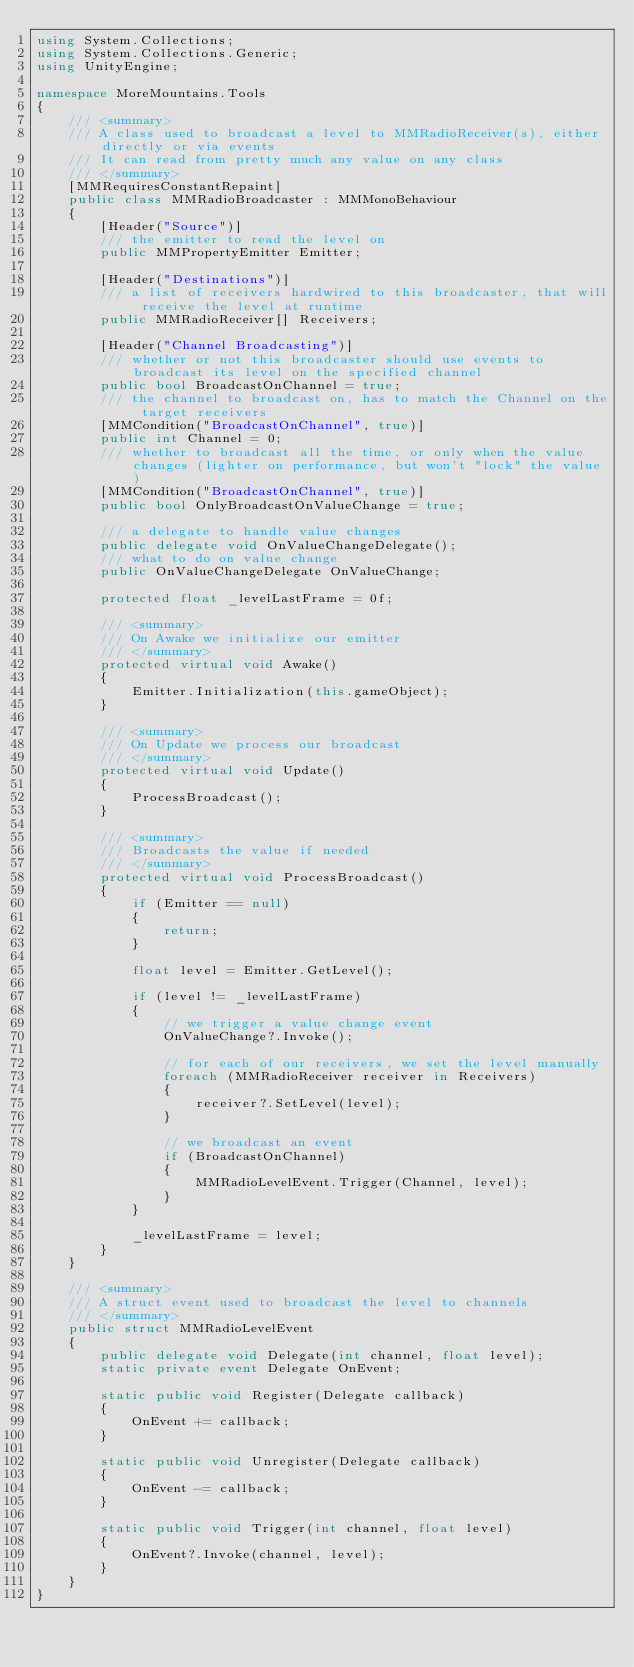Convert code to text. <code><loc_0><loc_0><loc_500><loc_500><_C#_>using System.Collections;
using System.Collections.Generic;
using UnityEngine;

namespace MoreMountains.Tools
{
    /// <summary>
    /// A class used to broadcast a level to MMRadioReceiver(s), either directly or via events
    /// It can read from pretty much any value on any class
    /// </summary>
    [MMRequiresConstantRepaint]
    public class MMRadioBroadcaster : MMMonoBehaviour
    {
        [Header("Source")]
        /// the emitter to read the level on
        public MMPropertyEmitter Emitter;

        [Header("Destinations")]
        /// a list of receivers hardwired to this broadcaster, that will receive the level at runtime
        public MMRadioReceiver[] Receivers;

        [Header("Channel Broadcasting")]
        /// whether or not this broadcaster should use events to broadcast its level on the specified channel
        public bool BroadcastOnChannel = true;
        /// the channel to broadcast on, has to match the Channel on the target receivers
        [MMCondition("BroadcastOnChannel", true)]
        public int Channel = 0;
        /// whether to broadcast all the time, or only when the value changes (lighter on performance, but won't "lock" the value)
        [MMCondition("BroadcastOnChannel", true)]
        public bool OnlyBroadcastOnValueChange = true;
        
        /// a delegate to handle value changes
        public delegate void OnValueChangeDelegate();
        /// what to do on value change
        public OnValueChangeDelegate OnValueChange;

        protected float _levelLastFrame = 0f;

        /// <summary>
        /// On Awake we initialize our emitter
        /// </summary>
        protected virtual void Awake()
        {
            Emitter.Initialization(this.gameObject);
        }

        /// <summary>
        /// On Update we process our broadcast
        /// </summary>
        protected virtual void Update()
        {
            ProcessBroadcast();
        }

        /// <summary>
        /// Broadcasts the value if needed
        /// </summary>
        protected virtual void ProcessBroadcast()
        {
            if (Emitter == null)
            {
                return;
            }

            float level = Emitter.GetLevel();

            if (level != _levelLastFrame)
            {
                // we trigger a value change event
                OnValueChange?.Invoke();

                // for each of our receivers, we set the level manually
                foreach (MMRadioReceiver receiver in Receivers)
                {
                    receiver?.SetLevel(level);
                }

                // we broadcast an event
                if (BroadcastOnChannel)
                {
                    MMRadioLevelEvent.Trigger(Channel, level);
                }
            }           

            _levelLastFrame = level;
        }
    }

    /// <summary>
    /// A struct event used to broadcast the level to channels
    /// </summary>
    public struct MMRadioLevelEvent
    {
        public delegate void Delegate(int channel, float level);
        static private event Delegate OnEvent;

        static public void Register(Delegate callback)
        {
            OnEvent += callback;
        }

        static public void Unregister(Delegate callback)
        {
            OnEvent -= callback;
        }

        static public void Trigger(int channel, float level)
        {
            OnEvent?.Invoke(channel, level);
        }
    }
}
</code> 